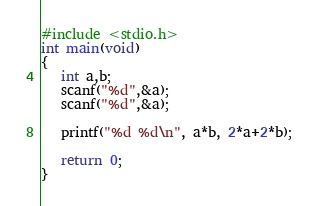Convert code to text. <code><loc_0><loc_0><loc_500><loc_500><_C_>#include <stdio.h>
int main(void)
{
   int a,b;
   scanf("%d",&a);
   scanf("%d",&a);

   printf("%d %d\n", a*b, 2*a+2*b);
  
   return 0;
}</code> 